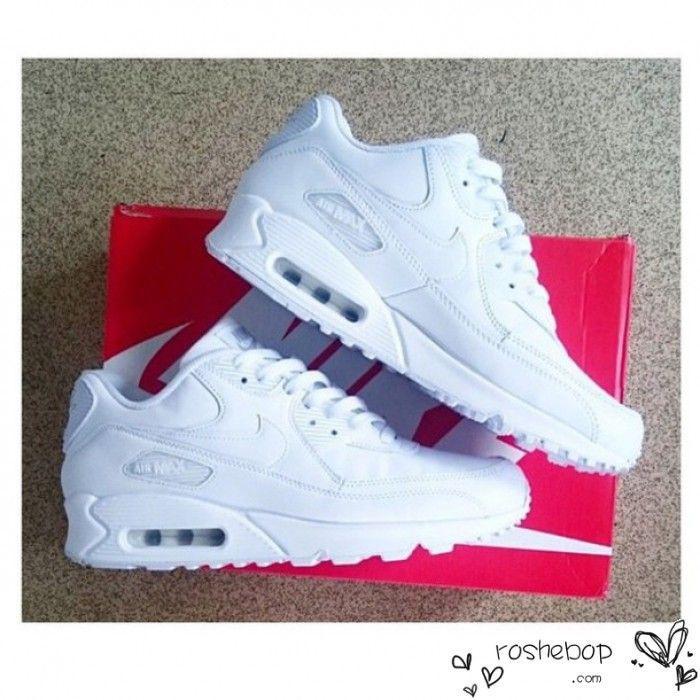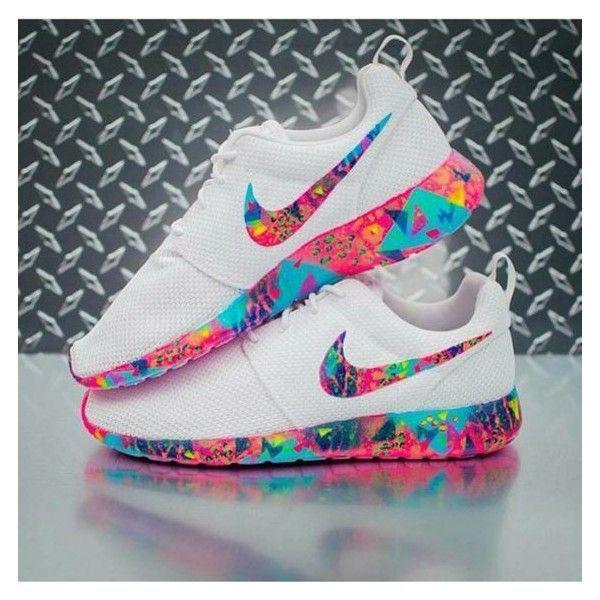The first image is the image on the left, the second image is the image on the right. Assess this claim about the two images: "A single shoe is shown in profile in each of the images.". Correct or not? Answer yes or no. No. The first image is the image on the left, the second image is the image on the right. Examine the images to the left and right. Is the description "Each image contains a single sneaker, and exactly one sneaker has pink laces." accurate? Answer yes or no. No. 